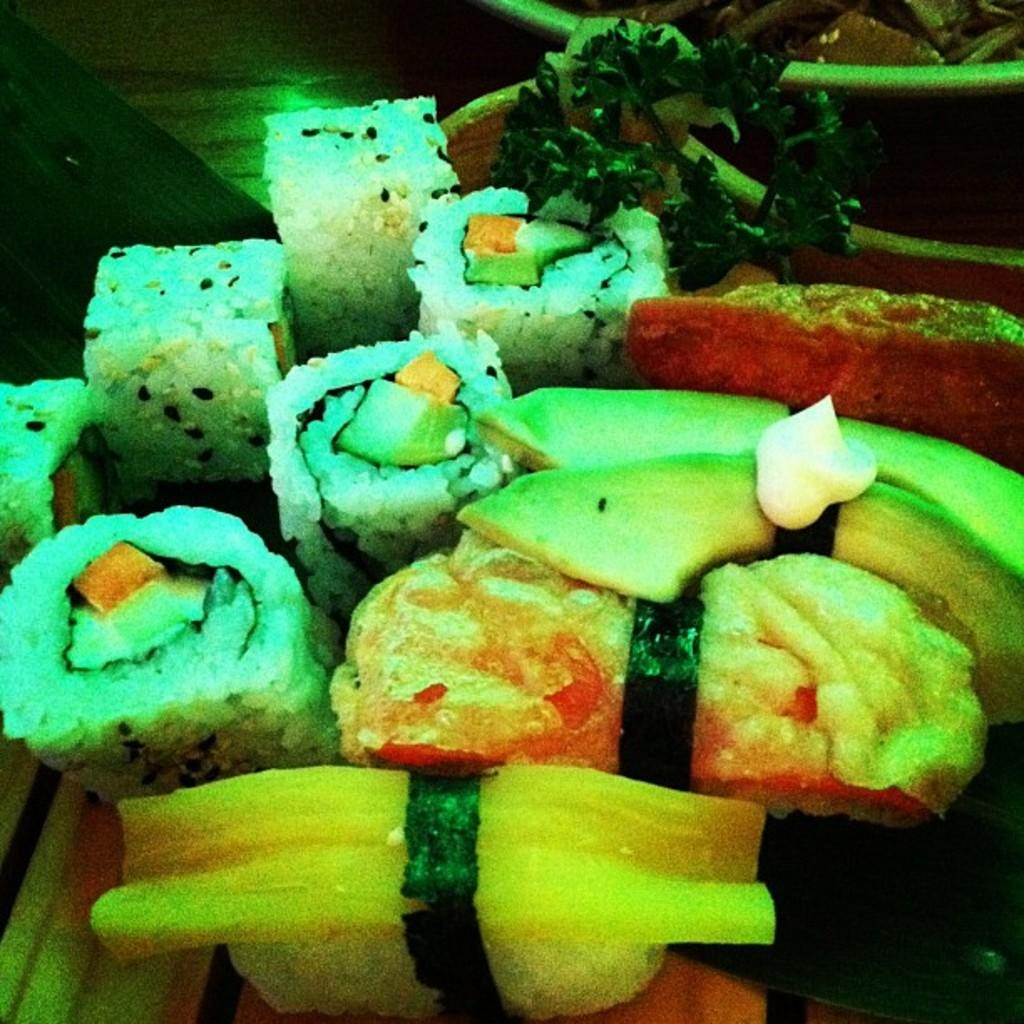What type of food can be seen in the image? There is sushi in the image. What other food items are present in the image? There are other food items in a bowl. What is the surface on which the food is displayed? The image appears to be on a wooden board. Can you confirm the presence of another plate in the image? The transcript is ambiguous about the presence of another plate, so it cannot be confirmed. How does the bean move around on the pig in the image? There is no bean or pig present in the image; it features sushi and other food items on a wooden board. 